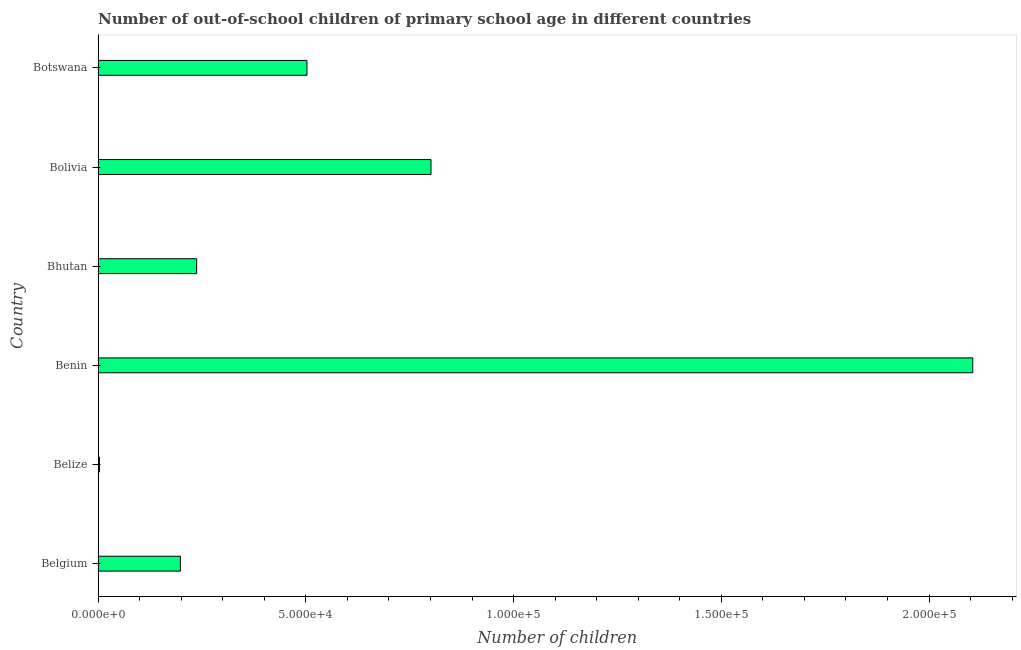Does the graph contain any zero values?
Ensure brevity in your answer.  No. What is the title of the graph?
Provide a succinct answer. Number of out-of-school children of primary school age in different countries. What is the label or title of the X-axis?
Your answer should be compact. Number of children. What is the number of out-of-school children in Belize?
Give a very brief answer. 327. Across all countries, what is the maximum number of out-of-school children?
Provide a short and direct response. 2.11e+05. Across all countries, what is the minimum number of out-of-school children?
Provide a succinct answer. 327. In which country was the number of out-of-school children maximum?
Provide a succinct answer. Benin. In which country was the number of out-of-school children minimum?
Your answer should be very brief. Belize. What is the sum of the number of out-of-school children?
Offer a very short reply. 3.85e+05. What is the difference between the number of out-of-school children in Belgium and Belize?
Ensure brevity in your answer.  1.95e+04. What is the average number of out-of-school children per country?
Your answer should be compact. 6.41e+04. What is the median number of out-of-school children?
Provide a succinct answer. 3.70e+04. In how many countries, is the number of out-of-school children greater than 100000 ?
Offer a very short reply. 1. What is the ratio of the number of out-of-school children in Bolivia to that in Botswana?
Offer a very short reply. 1.59. Is the number of out-of-school children in Benin less than that in Botswana?
Make the answer very short. No. Is the difference between the number of out-of-school children in Bhutan and Bolivia greater than the difference between any two countries?
Your response must be concise. No. What is the difference between the highest and the second highest number of out-of-school children?
Your answer should be compact. 1.30e+05. What is the difference between the highest and the lowest number of out-of-school children?
Give a very brief answer. 2.10e+05. How many bars are there?
Keep it short and to the point. 6. Are all the bars in the graph horizontal?
Offer a very short reply. Yes. How many countries are there in the graph?
Offer a terse response. 6. Are the values on the major ticks of X-axis written in scientific E-notation?
Ensure brevity in your answer.  Yes. What is the Number of children in Belgium?
Keep it short and to the point. 1.98e+04. What is the Number of children in Belize?
Ensure brevity in your answer.  327. What is the Number of children in Benin?
Your answer should be compact. 2.11e+05. What is the Number of children in Bhutan?
Provide a succinct answer. 2.37e+04. What is the Number of children of Bolivia?
Offer a very short reply. 8.01e+04. What is the Number of children in Botswana?
Make the answer very short. 5.03e+04. What is the difference between the Number of children in Belgium and Belize?
Offer a terse response. 1.95e+04. What is the difference between the Number of children in Belgium and Benin?
Ensure brevity in your answer.  -1.91e+05. What is the difference between the Number of children in Belgium and Bhutan?
Your response must be concise. -3914. What is the difference between the Number of children in Belgium and Bolivia?
Offer a terse response. -6.03e+04. What is the difference between the Number of children in Belgium and Botswana?
Ensure brevity in your answer.  -3.05e+04. What is the difference between the Number of children in Belize and Benin?
Your answer should be very brief. -2.10e+05. What is the difference between the Number of children in Belize and Bhutan?
Provide a short and direct response. -2.34e+04. What is the difference between the Number of children in Belize and Bolivia?
Offer a terse response. -7.98e+04. What is the difference between the Number of children in Belize and Botswana?
Provide a succinct answer. -4.99e+04. What is the difference between the Number of children in Benin and Bhutan?
Offer a terse response. 1.87e+05. What is the difference between the Number of children in Benin and Bolivia?
Ensure brevity in your answer.  1.30e+05. What is the difference between the Number of children in Benin and Botswana?
Ensure brevity in your answer.  1.60e+05. What is the difference between the Number of children in Bhutan and Bolivia?
Offer a terse response. -5.64e+04. What is the difference between the Number of children in Bhutan and Botswana?
Provide a short and direct response. -2.65e+04. What is the difference between the Number of children in Bolivia and Botswana?
Give a very brief answer. 2.99e+04. What is the ratio of the Number of children in Belgium to that in Belize?
Your answer should be compact. 60.58. What is the ratio of the Number of children in Belgium to that in Benin?
Give a very brief answer. 0.09. What is the ratio of the Number of children in Belgium to that in Bhutan?
Offer a very short reply. 0.83. What is the ratio of the Number of children in Belgium to that in Bolivia?
Your response must be concise. 0.25. What is the ratio of the Number of children in Belgium to that in Botswana?
Offer a very short reply. 0.39. What is the ratio of the Number of children in Belize to that in Benin?
Offer a very short reply. 0. What is the ratio of the Number of children in Belize to that in Bhutan?
Ensure brevity in your answer.  0.01. What is the ratio of the Number of children in Belize to that in Bolivia?
Make the answer very short. 0. What is the ratio of the Number of children in Belize to that in Botswana?
Provide a short and direct response. 0.01. What is the ratio of the Number of children in Benin to that in Bhutan?
Your answer should be compact. 8.87. What is the ratio of the Number of children in Benin to that in Bolivia?
Provide a short and direct response. 2.63. What is the ratio of the Number of children in Benin to that in Botswana?
Provide a short and direct response. 4.19. What is the ratio of the Number of children in Bhutan to that in Bolivia?
Offer a terse response. 0.3. What is the ratio of the Number of children in Bhutan to that in Botswana?
Your answer should be very brief. 0.47. What is the ratio of the Number of children in Bolivia to that in Botswana?
Your response must be concise. 1.59. 